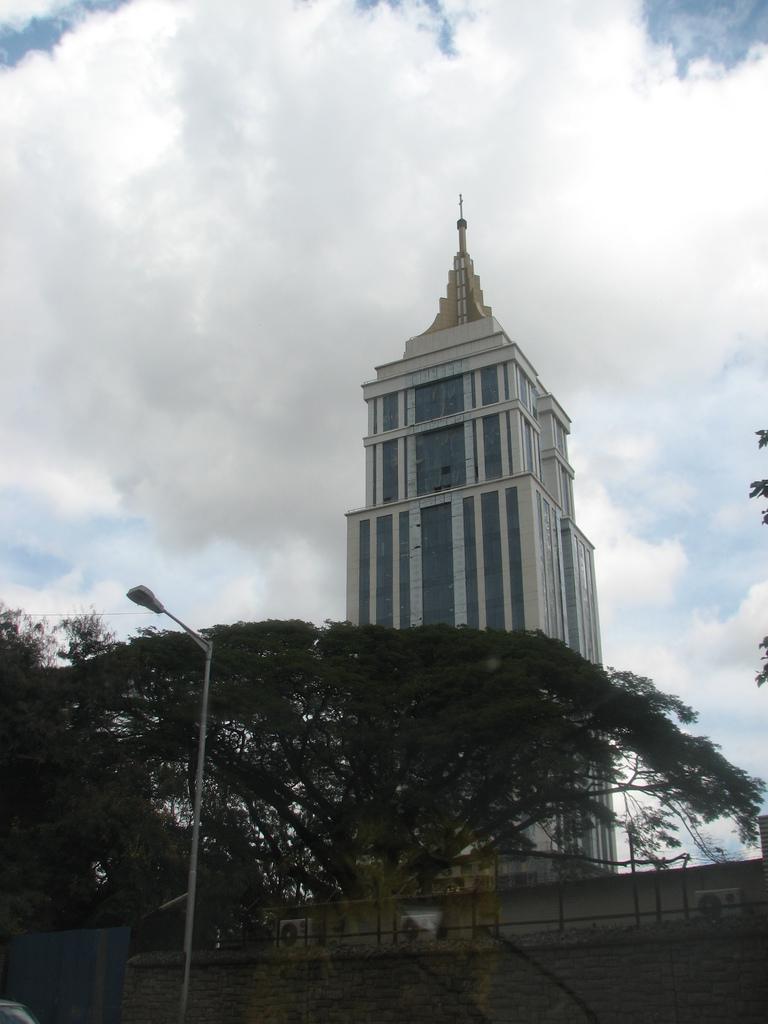In one or two sentences, can you explain what this image depicts? In this picture, on the left side, we can see a street light. In the background, we can see a wall, trees, air conditioner, tower. At the top, we can see a sky. 